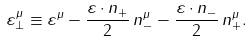Convert formula to latex. <formula><loc_0><loc_0><loc_500><loc_500>\varepsilon _ { \perp } ^ { \mu } \equiv \varepsilon ^ { \mu } - \frac { \varepsilon \cdot n _ { + } } { 2 } \, n _ { - } ^ { \mu } - \frac { \varepsilon \cdot n _ { - } } { 2 } \, n _ { + } ^ { \mu } .</formula> 